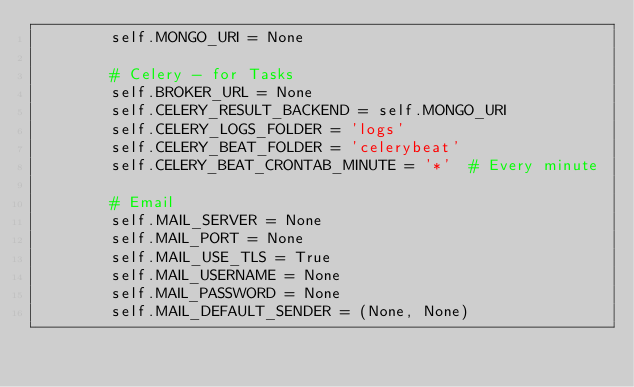<code> <loc_0><loc_0><loc_500><loc_500><_Python_>        self.MONGO_URI = None

        # Celery - for Tasks
        self.BROKER_URL = None
        self.CELERY_RESULT_BACKEND = self.MONGO_URI
        self.CELERY_LOGS_FOLDER = 'logs'
        self.CELERY_BEAT_FOLDER = 'celerybeat'
        self.CELERY_BEAT_CRONTAB_MINUTE = '*'  # Every minute

        # Email
        self.MAIL_SERVER = None
        self.MAIL_PORT = None
        self.MAIL_USE_TLS = True
        self.MAIL_USERNAME = None
        self.MAIL_PASSWORD = None
        self.MAIL_DEFAULT_SENDER = (None, None)
</code> 